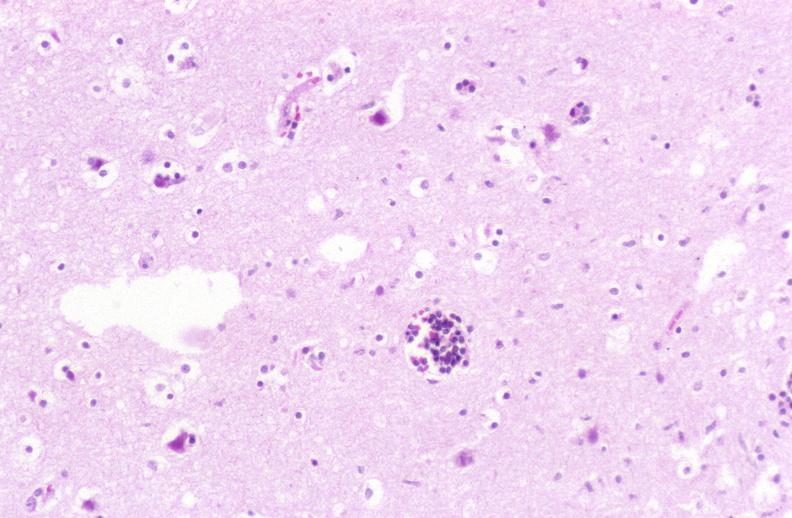does di george syndrome show brain, herpes encephalitis, perivascular cuffing?
Answer the question using a single word or phrase. No 